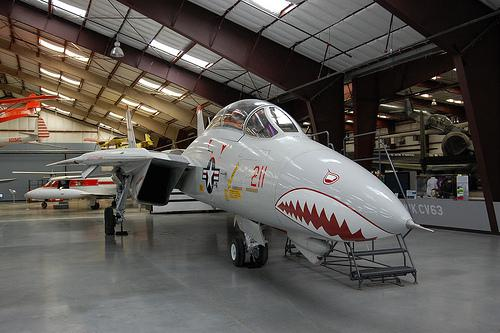Question: where is this plane?
Choices:
A. On the runway.
B. In the air.
C. A hanger.
D. Abovel the clouds.
Answer with the letter. Answer: C Question: how many wings does the plane have?
Choices:
A. Three.
B. Four.
C. Two.
D. One.
Answer with the letter. Answer: C Question: what is the color of the ground?
Choices:
A. Green.
B. Brown.
C. White.
D. Grey.
Answer with the letter. Answer: D Question: what number is on the plane?
Choices:
A. 513.
B. 628.
C. 211.
D. 732.
Answer with the letter. Answer: C Question: what is in this hangar?
Choices:
A. Jets.
B. B2 bombers.
C. Stealth fighters.
D. Planes.
Answer with the letter. Answer: D 